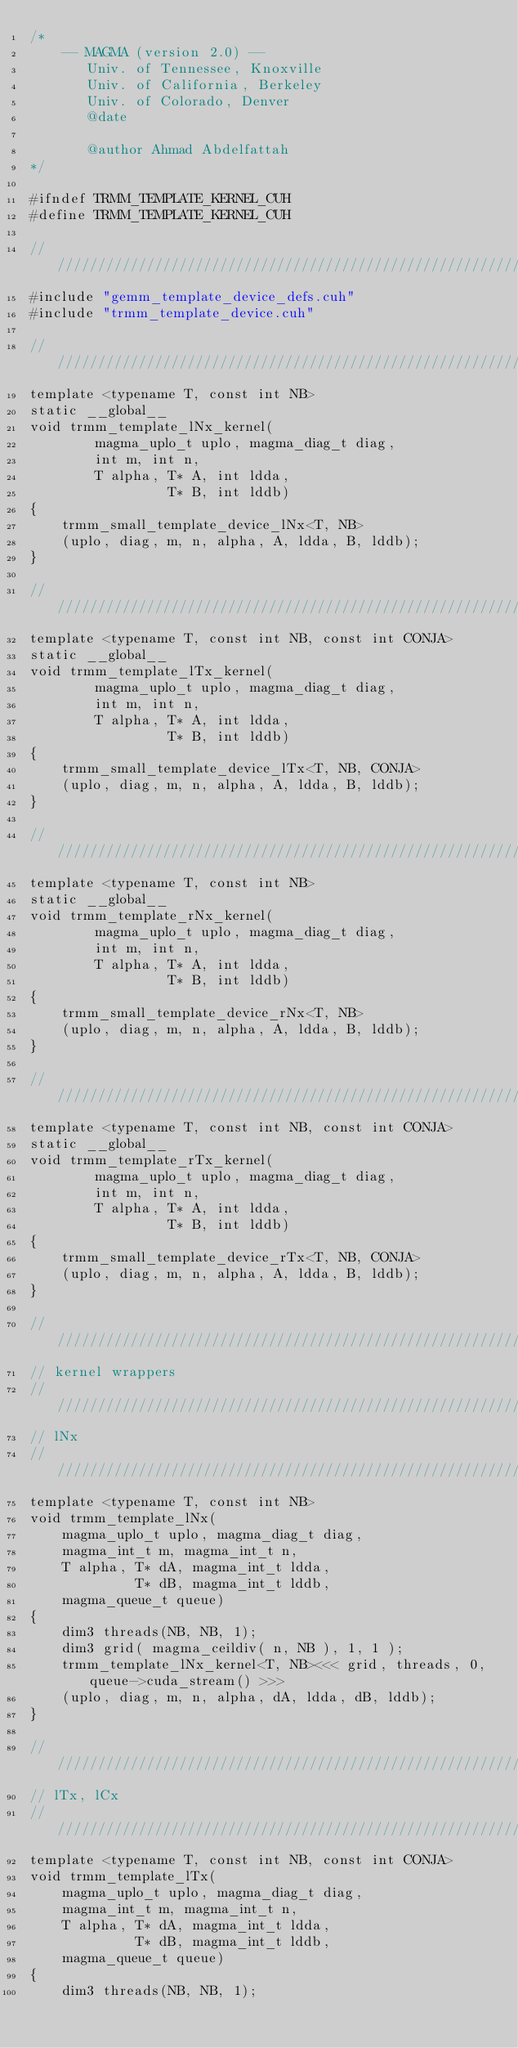<code> <loc_0><loc_0><loc_500><loc_500><_Cuda_>/*
    -- MAGMA (version 2.0) --
       Univ. of Tennessee, Knoxville
       Univ. of California, Berkeley
       Univ. of Colorado, Denver
       @date
       
       @author Ahmad Abdelfattah
*/

#ifndef TRMM_TEMPLATE_KERNEL_CUH
#define TRMM_TEMPLATE_KERNEL_CUH

////////////////////////////////////////////////////////////////////////////////////////////////////
#include "gemm_template_device_defs.cuh"
#include "trmm_template_device.cuh"

////////////////////////////////////////////////////////////////////////////////////////////////////
template <typename T, const int NB>
static __global__
void trmm_template_lNx_kernel(
        magma_uplo_t uplo, magma_diag_t diag, 
        int m, int n, 
        T alpha, T* A, int ldda, 
                 T* B, int lddb)
{
    trmm_small_template_device_lNx<T, NB>
    (uplo, diag, m, n, alpha, A, ldda, B, lddb);
}

////////////////////////////////////////////////////////////////////////////////////////////////////
template <typename T, const int NB, const int CONJA>
static __global__
void trmm_template_lTx_kernel(
        magma_uplo_t uplo, magma_diag_t diag, 
        int m, int n, 
        T alpha, T* A, int ldda, 
                 T* B, int lddb)
{
    trmm_small_template_device_lTx<T, NB, CONJA>
    (uplo, diag, m, n, alpha, A, ldda, B, lddb);
}

////////////////////////////////////////////////////////////////////////////////////////////////////
template <typename T, const int NB>
static __global__
void trmm_template_rNx_kernel(
        magma_uplo_t uplo, magma_diag_t diag, 
        int m, int n, 
        T alpha, T* A, int ldda, 
                 T* B, int lddb)
{
    trmm_small_template_device_rNx<T, NB>
    (uplo, diag, m, n, alpha, A, ldda, B, lddb);
}

////////////////////////////////////////////////////////////////////////////////////////////////////
template <typename T, const int NB, const int CONJA>
static __global__
void trmm_template_rTx_kernel(
        magma_uplo_t uplo, magma_diag_t diag, 
        int m, int n, 
        T alpha, T* A, int ldda, 
                 T* B, int lddb)
{
    trmm_small_template_device_rTx<T, NB, CONJA>
    (uplo, diag, m, n, alpha, A, ldda, B, lddb);
}

////////////////////////////////////////////////////////////////////////////////////////////////////
// kernel wrappers
////////////////////////////////////////////////////////////////////////////////////////////////////
// lNx 
////////////////////////////////////////////////////////////////////////////////////////////////////
template <typename T, const int NB>
void trmm_template_lNx(
    magma_uplo_t uplo, magma_diag_t diag, 
    magma_int_t m, magma_int_t n, 
    T alpha, T* dA, magma_int_t ldda,
             T* dB, magma_int_t lddb,
    magma_queue_t queue)
{
    dim3 threads(NB, NB, 1);
    dim3 grid( magma_ceildiv( n, NB ), 1, 1 );
    trmm_template_lNx_kernel<T, NB><<< grid, threads, 0, queue->cuda_stream() >>>
    (uplo, diag, m, n, alpha, dA, ldda, dB, lddb);
}

////////////////////////////////////////////////////////////////////////////////////////////////////
// lTx, lCx 
////////////////////////////////////////////////////////////////////////////////////////////////////
template <typename T, const int NB, const int CONJA>
void trmm_template_lTx(
    magma_uplo_t uplo, magma_diag_t diag, 
    magma_int_t m, magma_int_t n, 
    T alpha, T* dA, magma_int_t ldda,
             T* dB, magma_int_t lddb,
    magma_queue_t queue)
{
    dim3 threads(NB, NB, 1);</code> 